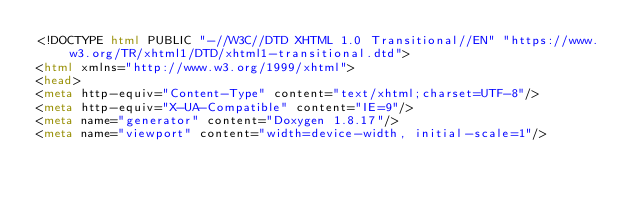Convert code to text. <code><loc_0><loc_0><loc_500><loc_500><_HTML_><!DOCTYPE html PUBLIC "-//W3C//DTD XHTML 1.0 Transitional//EN" "https://www.w3.org/TR/xhtml1/DTD/xhtml1-transitional.dtd">
<html xmlns="http://www.w3.org/1999/xhtml">
<head>
<meta http-equiv="Content-Type" content="text/xhtml;charset=UTF-8"/>
<meta http-equiv="X-UA-Compatible" content="IE=9"/>
<meta name="generator" content="Doxygen 1.8.17"/>
<meta name="viewport" content="width=device-width, initial-scale=1"/></code> 